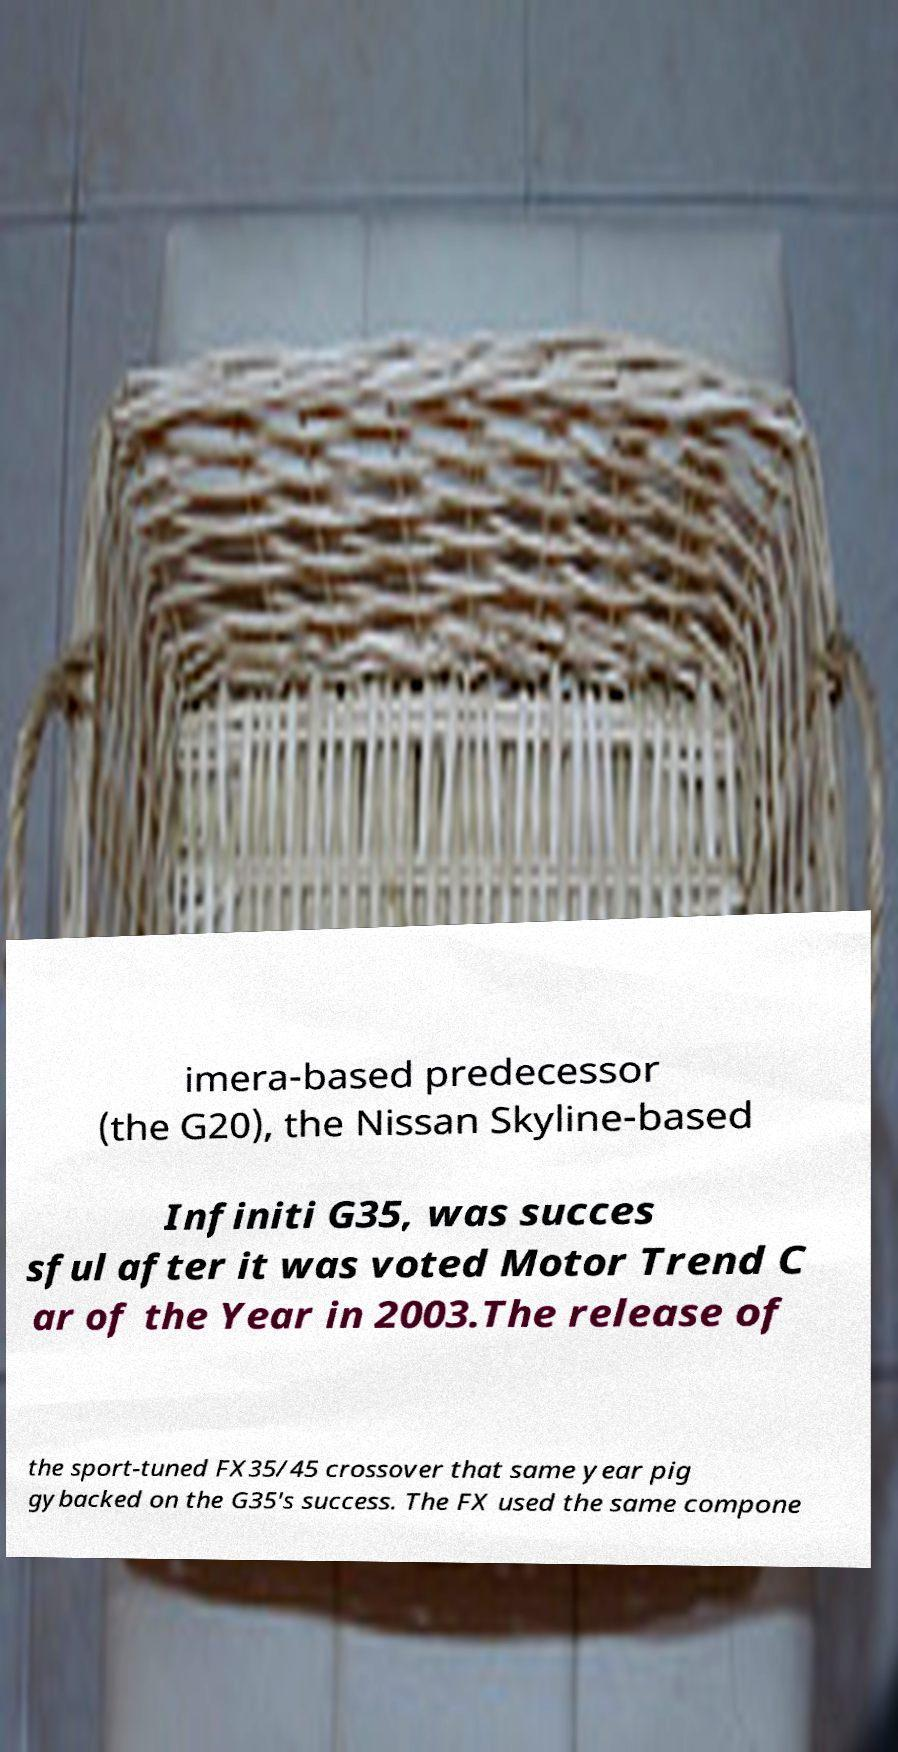Please identify and transcribe the text found in this image. imera-based predecessor (the G20), the Nissan Skyline-based Infiniti G35, was succes sful after it was voted Motor Trend C ar of the Year in 2003.The release of the sport-tuned FX35/45 crossover that same year pig gybacked on the G35's success. The FX used the same compone 